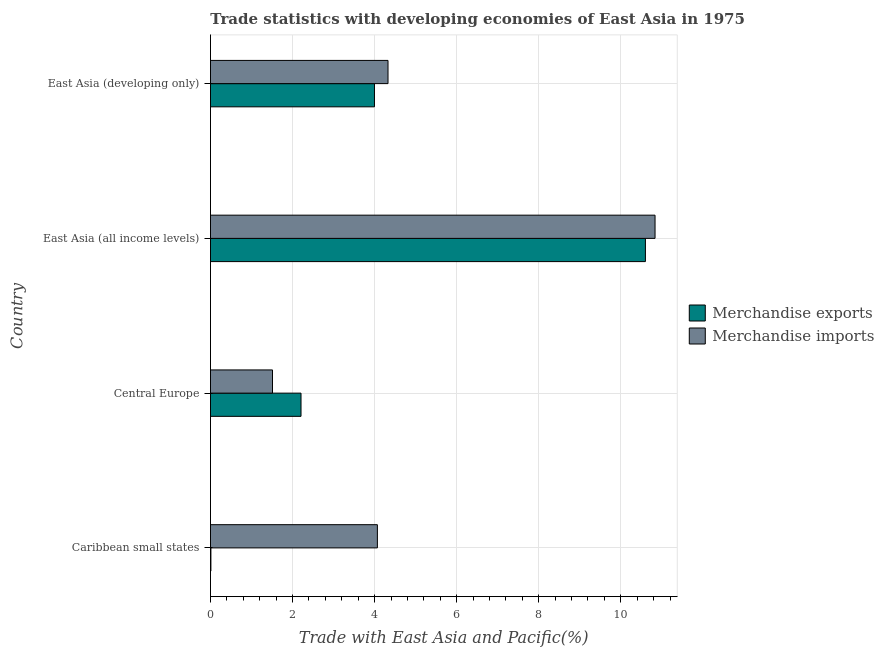How many different coloured bars are there?
Your answer should be compact. 2. How many groups of bars are there?
Give a very brief answer. 4. Are the number of bars on each tick of the Y-axis equal?
Offer a very short reply. Yes. How many bars are there on the 3rd tick from the top?
Your answer should be very brief. 2. How many bars are there on the 4th tick from the bottom?
Ensure brevity in your answer.  2. What is the label of the 3rd group of bars from the top?
Keep it short and to the point. Central Europe. What is the merchandise exports in Caribbean small states?
Your answer should be very brief. 0.01. Across all countries, what is the maximum merchandise imports?
Provide a short and direct response. 10.83. Across all countries, what is the minimum merchandise exports?
Your response must be concise. 0.01. In which country was the merchandise exports maximum?
Your answer should be very brief. East Asia (all income levels). In which country was the merchandise exports minimum?
Provide a short and direct response. Caribbean small states. What is the total merchandise imports in the graph?
Provide a succinct answer. 20.74. What is the difference between the merchandise exports in Caribbean small states and that in Central Europe?
Ensure brevity in your answer.  -2.2. What is the difference between the merchandise imports in Central Europe and the merchandise exports in Caribbean small states?
Keep it short and to the point. 1.5. What is the average merchandise imports per country?
Your response must be concise. 5.18. What is the difference between the merchandise imports and merchandise exports in East Asia (all income levels)?
Your answer should be very brief. 0.23. What is the ratio of the merchandise exports in East Asia (all income levels) to that in East Asia (developing only)?
Provide a succinct answer. 2.65. Is the merchandise exports in East Asia (all income levels) less than that in East Asia (developing only)?
Offer a very short reply. No. Is the difference between the merchandise exports in Caribbean small states and East Asia (developing only) greater than the difference between the merchandise imports in Caribbean small states and East Asia (developing only)?
Your response must be concise. No. What is the difference between the highest and the second highest merchandise imports?
Keep it short and to the point. 6.51. What is the difference between the highest and the lowest merchandise exports?
Provide a short and direct response. 10.59. In how many countries, is the merchandise imports greater than the average merchandise imports taken over all countries?
Ensure brevity in your answer.  1. What does the 2nd bar from the top in Caribbean small states represents?
Give a very brief answer. Merchandise exports. What does the 1st bar from the bottom in Central Europe represents?
Keep it short and to the point. Merchandise exports. Are all the bars in the graph horizontal?
Make the answer very short. Yes. How many countries are there in the graph?
Offer a terse response. 4. Does the graph contain any zero values?
Offer a very short reply. No. Does the graph contain grids?
Your answer should be compact. Yes. Where does the legend appear in the graph?
Give a very brief answer. Center right. What is the title of the graph?
Your response must be concise. Trade statistics with developing economies of East Asia in 1975. What is the label or title of the X-axis?
Your response must be concise. Trade with East Asia and Pacific(%). What is the label or title of the Y-axis?
Your answer should be compact. Country. What is the Trade with East Asia and Pacific(%) in Merchandise exports in Caribbean small states?
Make the answer very short. 0.01. What is the Trade with East Asia and Pacific(%) of Merchandise imports in Caribbean small states?
Your response must be concise. 4.07. What is the Trade with East Asia and Pacific(%) of Merchandise exports in Central Europe?
Offer a terse response. 2.21. What is the Trade with East Asia and Pacific(%) in Merchandise imports in Central Europe?
Your response must be concise. 1.51. What is the Trade with East Asia and Pacific(%) in Merchandise exports in East Asia (all income levels)?
Offer a terse response. 10.6. What is the Trade with East Asia and Pacific(%) of Merchandise imports in East Asia (all income levels)?
Offer a terse response. 10.83. What is the Trade with East Asia and Pacific(%) in Merchandise exports in East Asia (developing only)?
Your response must be concise. 4. What is the Trade with East Asia and Pacific(%) in Merchandise imports in East Asia (developing only)?
Offer a terse response. 4.33. Across all countries, what is the maximum Trade with East Asia and Pacific(%) in Merchandise exports?
Make the answer very short. 10.6. Across all countries, what is the maximum Trade with East Asia and Pacific(%) in Merchandise imports?
Make the answer very short. 10.83. Across all countries, what is the minimum Trade with East Asia and Pacific(%) in Merchandise exports?
Provide a short and direct response. 0.01. Across all countries, what is the minimum Trade with East Asia and Pacific(%) in Merchandise imports?
Your answer should be very brief. 1.51. What is the total Trade with East Asia and Pacific(%) in Merchandise exports in the graph?
Ensure brevity in your answer.  16.81. What is the total Trade with East Asia and Pacific(%) of Merchandise imports in the graph?
Offer a very short reply. 20.74. What is the difference between the Trade with East Asia and Pacific(%) of Merchandise exports in Caribbean small states and that in Central Europe?
Ensure brevity in your answer.  -2.2. What is the difference between the Trade with East Asia and Pacific(%) of Merchandise imports in Caribbean small states and that in Central Europe?
Keep it short and to the point. 2.56. What is the difference between the Trade with East Asia and Pacific(%) in Merchandise exports in Caribbean small states and that in East Asia (all income levels)?
Give a very brief answer. -10.59. What is the difference between the Trade with East Asia and Pacific(%) in Merchandise imports in Caribbean small states and that in East Asia (all income levels)?
Give a very brief answer. -6.77. What is the difference between the Trade with East Asia and Pacific(%) in Merchandise exports in Caribbean small states and that in East Asia (developing only)?
Provide a short and direct response. -3.99. What is the difference between the Trade with East Asia and Pacific(%) in Merchandise imports in Caribbean small states and that in East Asia (developing only)?
Your answer should be compact. -0.26. What is the difference between the Trade with East Asia and Pacific(%) in Merchandise exports in Central Europe and that in East Asia (all income levels)?
Offer a terse response. -8.39. What is the difference between the Trade with East Asia and Pacific(%) in Merchandise imports in Central Europe and that in East Asia (all income levels)?
Give a very brief answer. -9.32. What is the difference between the Trade with East Asia and Pacific(%) in Merchandise exports in Central Europe and that in East Asia (developing only)?
Ensure brevity in your answer.  -1.79. What is the difference between the Trade with East Asia and Pacific(%) in Merchandise imports in Central Europe and that in East Asia (developing only)?
Your answer should be very brief. -2.82. What is the difference between the Trade with East Asia and Pacific(%) of Merchandise exports in East Asia (all income levels) and that in East Asia (developing only)?
Offer a terse response. 6.6. What is the difference between the Trade with East Asia and Pacific(%) of Merchandise imports in East Asia (all income levels) and that in East Asia (developing only)?
Give a very brief answer. 6.51. What is the difference between the Trade with East Asia and Pacific(%) of Merchandise exports in Caribbean small states and the Trade with East Asia and Pacific(%) of Merchandise imports in Central Europe?
Provide a succinct answer. -1.5. What is the difference between the Trade with East Asia and Pacific(%) in Merchandise exports in Caribbean small states and the Trade with East Asia and Pacific(%) in Merchandise imports in East Asia (all income levels)?
Offer a very short reply. -10.82. What is the difference between the Trade with East Asia and Pacific(%) of Merchandise exports in Caribbean small states and the Trade with East Asia and Pacific(%) of Merchandise imports in East Asia (developing only)?
Provide a succinct answer. -4.32. What is the difference between the Trade with East Asia and Pacific(%) in Merchandise exports in Central Europe and the Trade with East Asia and Pacific(%) in Merchandise imports in East Asia (all income levels)?
Keep it short and to the point. -8.63. What is the difference between the Trade with East Asia and Pacific(%) in Merchandise exports in Central Europe and the Trade with East Asia and Pacific(%) in Merchandise imports in East Asia (developing only)?
Ensure brevity in your answer.  -2.12. What is the difference between the Trade with East Asia and Pacific(%) in Merchandise exports in East Asia (all income levels) and the Trade with East Asia and Pacific(%) in Merchandise imports in East Asia (developing only)?
Your response must be concise. 6.27. What is the average Trade with East Asia and Pacific(%) in Merchandise exports per country?
Make the answer very short. 4.2. What is the average Trade with East Asia and Pacific(%) in Merchandise imports per country?
Keep it short and to the point. 5.18. What is the difference between the Trade with East Asia and Pacific(%) of Merchandise exports and Trade with East Asia and Pacific(%) of Merchandise imports in Caribbean small states?
Offer a very short reply. -4.06. What is the difference between the Trade with East Asia and Pacific(%) of Merchandise exports and Trade with East Asia and Pacific(%) of Merchandise imports in Central Europe?
Your answer should be very brief. 0.7. What is the difference between the Trade with East Asia and Pacific(%) in Merchandise exports and Trade with East Asia and Pacific(%) in Merchandise imports in East Asia (all income levels)?
Offer a very short reply. -0.23. What is the difference between the Trade with East Asia and Pacific(%) in Merchandise exports and Trade with East Asia and Pacific(%) in Merchandise imports in East Asia (developing only)?
Make the answer very short. -0.33. What is the ratio of the Trade with East Asia and Pacific(%) in Merchandise exports in Caribbean small states to that in Central Europe?
Provide a succinct answer. 0. What is the ratio of the Trade with East Asia and Pacific(%) of Merchandise imports in Caribbean small states to that in Central Europe?
Keep it short and to the point. 2.69. What is the ratio of the Trade with East Asia and Pacific(%) of Merchandise exports in Caribbean small states to that in East Asia (all income levels)?
Your response must be concise. 0. What is the ratio of the Trade with East Asia and Pacific(%) of Merchandise imports in Caribbean small states to that in East Asia (all income levels)?
Ensure brevity in your answer.  0.38. What is the ratio of the Trade with East Asia and Pacific(%) in Merchandise exports in Caribbean small states to that in East Asia (developing only)?
Offer a terse response. 0. What is the ratio of the Trade with East Asia and Pacific(%) of Merchandise imports in Caribbean small states to that in East Asia (developing only)?
Provide a short and direct response. 0.94. What is the ratio of the Trade with East Asia and Pacific(%) of Merchandise exports in Central Europe to that in East Asia (all income levels)?
Ensure brevity in your answer.  0.21. What is the ratio of the Trade with East Asia and Pacific(%) of Merchandise imports in Central Europe to that in East Asia (all income levels)?
Offer a terse response. 0.14. What is the ratio of the Trade with East Asia and Pacific(%) of Merchandise exports in Central Europe to that in East Asia (developing only)?
Ensure brevity in your answer.  0.55. What is the ratio of the Trade with East Asia and Pacific(%) of Merchandise imports in Central Europe to that in East Asia (developing only)?
Your answer should be compact. 0.35. What is the ratio of the Trade with East Asia and Pacific(%) in Merchandise exports in East Asia (all income levels) to that in East Asia (developing only)?
Make the answer very short. 2.65. What is the ratio of the Trade with East Asia and Pacific(%) of Merchandise imports in East Asia (all income levels) to that in East Asia (developing only)?
Provide a short and direct response. 2.5. What is the difference between the highest and the second highest Trade with East Asia and Pacific(%) of Merchandise exports?
Keep it short and to the point. 6.6. What is the difference between the highest and the second highest Trade with East Asia and Pacific(%) of Merchandise imports?
Ensure brevity in your answer.  6.51. What is the difference between the highest and the lowest Trade with East Asia and Pacific(%) of Merchandise exports?
Offer a terse response. 10.59. What is the difference between the highest and the lowest Trade with East Asia and Pacific(%) in Merchandise imports?
Offer a very short reply. 9.32. 